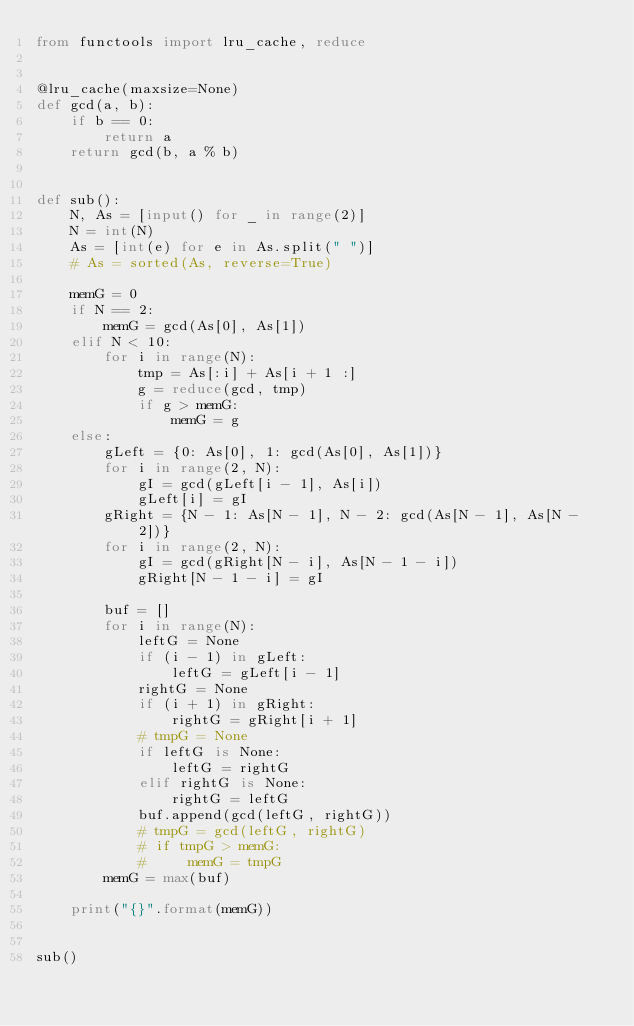Convert code to text. <code><loc_0><loc_0><loc_500><loc_500><_Python_>from functools import lru_cache, reduce


@lru_cache(maxsize=None)
def gcd(a, b):
    if b == 0:
        return a
    return gcd(b, a % b)


def sub():
    N, As = [input() for _ in range(2)]
    N = int(N)
    As = [int(e) for e in As.split(" ")]
    # As = sorted(As, reverse=True)

    memG = 0
    if N == 2:
        memG = gcd(As[0], As[1])
    elif N < 10:
        for i in range(N):
            tmp = As[:i] + As[i + 1 :]
            g = reduce(gcd, tmp)
            if g > memG:
                memG = g
    else:
        gLeft = {0: As[0], 1: gcd(As[0], As[1])}
        for i in range(2, N):
            gI = gcd(gLeft[i - 1], As[i])
            gLeft[i] = gI
        gRight = {N - 1: As[N - 1], N - 2: gcd(As[N - 1], As[N - 2])}
        for i in range(2, N):
            gI = gcd(gRight[N - i], As[N - 1 - i])
            gRight[N - 1 - i] = gI

        buf = []
        for i in range(N):
            leftG = None
            if (i - 1) in gLeft:
                leftG = gLeft[i - 1]
            rightG = None
            if (i + 1) in gRight:
                rightG = gRight[i + 1]
            # tmpG = None
            if leftG is None:
                leftG = rightG
            elif rightG is None:
                rightG = leftG
            buf.append(gcd(leftG, rightG))
            # tmpG = gcd(leftG, rightG)
            # if tmpG > memG:
            #     memG = tmpG
        memG = max(buf)

    print("{}".format(memG))


sub()
</code> 